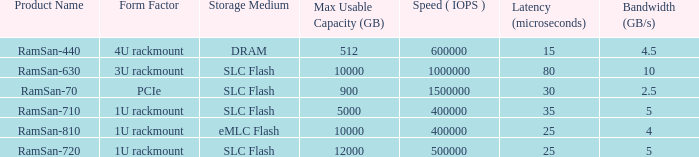What is the delay in transferring ramsan-810? 1.0. 